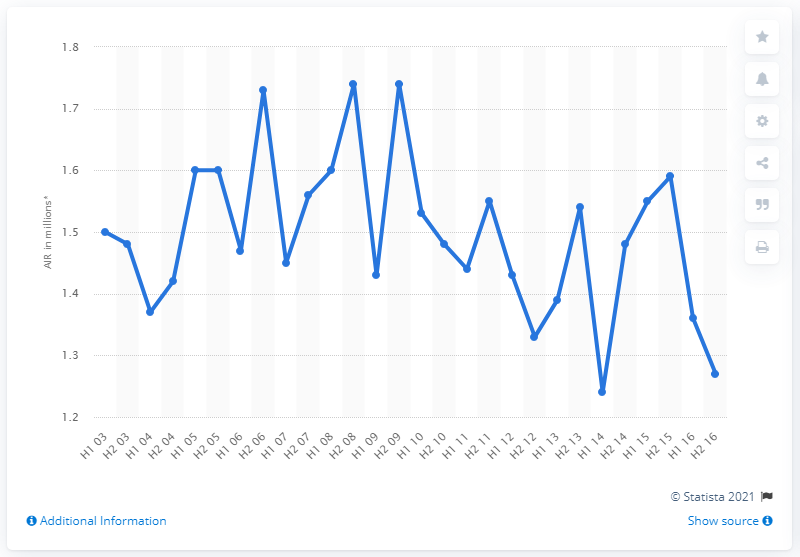Specify some key components in this picture. Good Housekeeping magazine had an average of 1.59 readers per issue in the second half of 2015. 